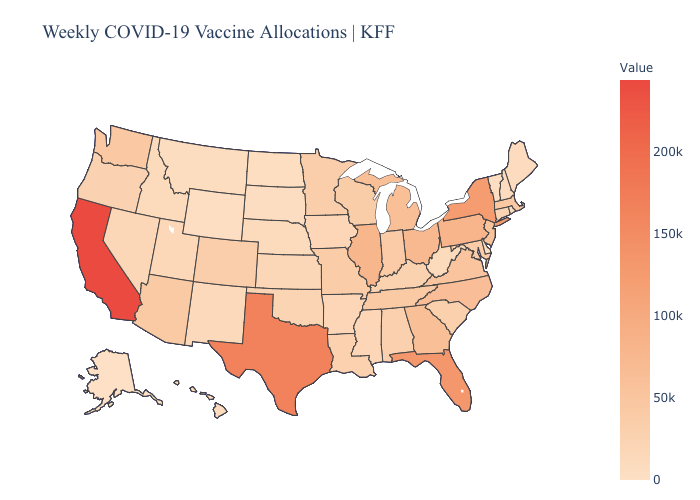Among the states that border Delaware , does Maryland have the highest value?
Concise answer only. No. Which states have the highest value in the USA?
Be succinct. California. Which states have the lowest value in the West?
Short answer required. Alaska. Which states have the lowest value in the Northeast?
Be succinct. Vermont. Among the states that border Montana , which have the lowest value?
Keep it brief. Wyoming. Which states have the lowest value in the USA?
Short answer required. Alaska. Among the states that border Florida , which have the lowest value?
Answer briefly. Alabama. Among the states that border West Virginia , which have the lowest value?
Write a very short answer. Kentucky. 